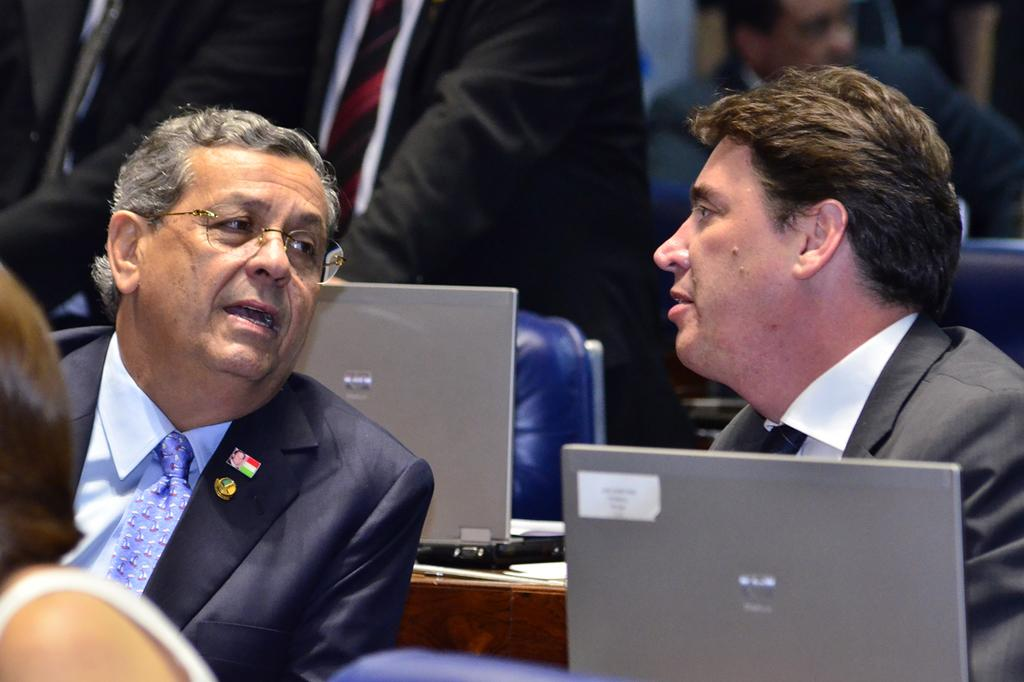How many people are sitting in the image? There are two persons sitting in the image. What objects are on the tables in the image? There are laptops on the tables in the image. Can you describe the background of the image? There is a group of people in the background of the image. What type of locket is hanging from the lamp in the image? There is no locket or lamp present in the image. How does the person sitting on the left fall in the image? There is no person falling in the image; both persons are sitting. 